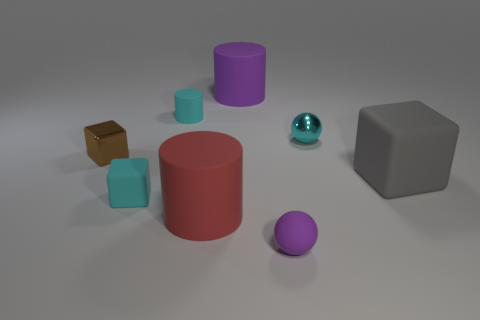Do the purple object in front of the small brown shiny cube and the cylinder that is in front of the small cyan cylinder have the same size?
Make the answer very short. No. How many other objects are there of the same color as the rubber sphere?
Give a very brief answer. 1. There is a cyan cube; is its size the same as the ball that is in front of the large gray matte cube?
Offer a terse response. Yes. There is a cyan rubber thing that is behind the big matte object on the right side of the big purple matte thing; what size is it?
Your answer should be compact. Small. There is a large rubber object that is the same shape as the tiny brown object; what is its color?
Provide a succinct answer. Gray. Do the cyan rubber cylinder and the brown metallic thing have the same size?
Your answer should be very brief. Yes. Are there the same number of tiny shiny balls in front of the red object and large red matte cylinders?
Ensure brevity in your answer.  No. There is a tiny metal thing right of the small purple matte object; are there any things on the right side of it?
Offer a terse response. Yes. There is a matte sphere in front of the tiny matte object that is behind the small block that is in front of the brown metallic object; how big is it?
Your answer should be compact. Small. What material is the tiny brown block on the left side of the metallic sphere behind the cyan rubber block?
Your response must be concise. Metal. 